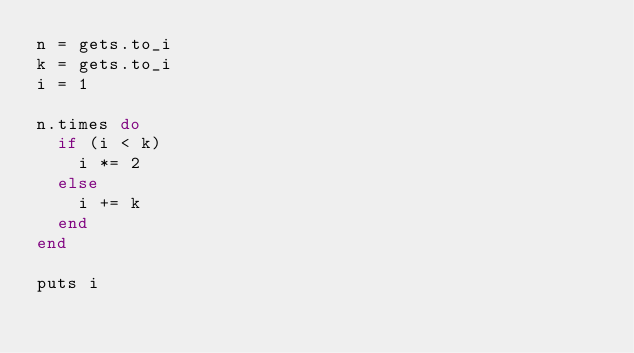<code> <loc_0><loc_0><loc_500><loc_500><_Ruby_>n = gets.to_i
k = gets.to_i
i = 1
 
n.times do
  if (i < k)
    i *= 2
  else
    i += k
  end
end
 
puts i
  </code> 